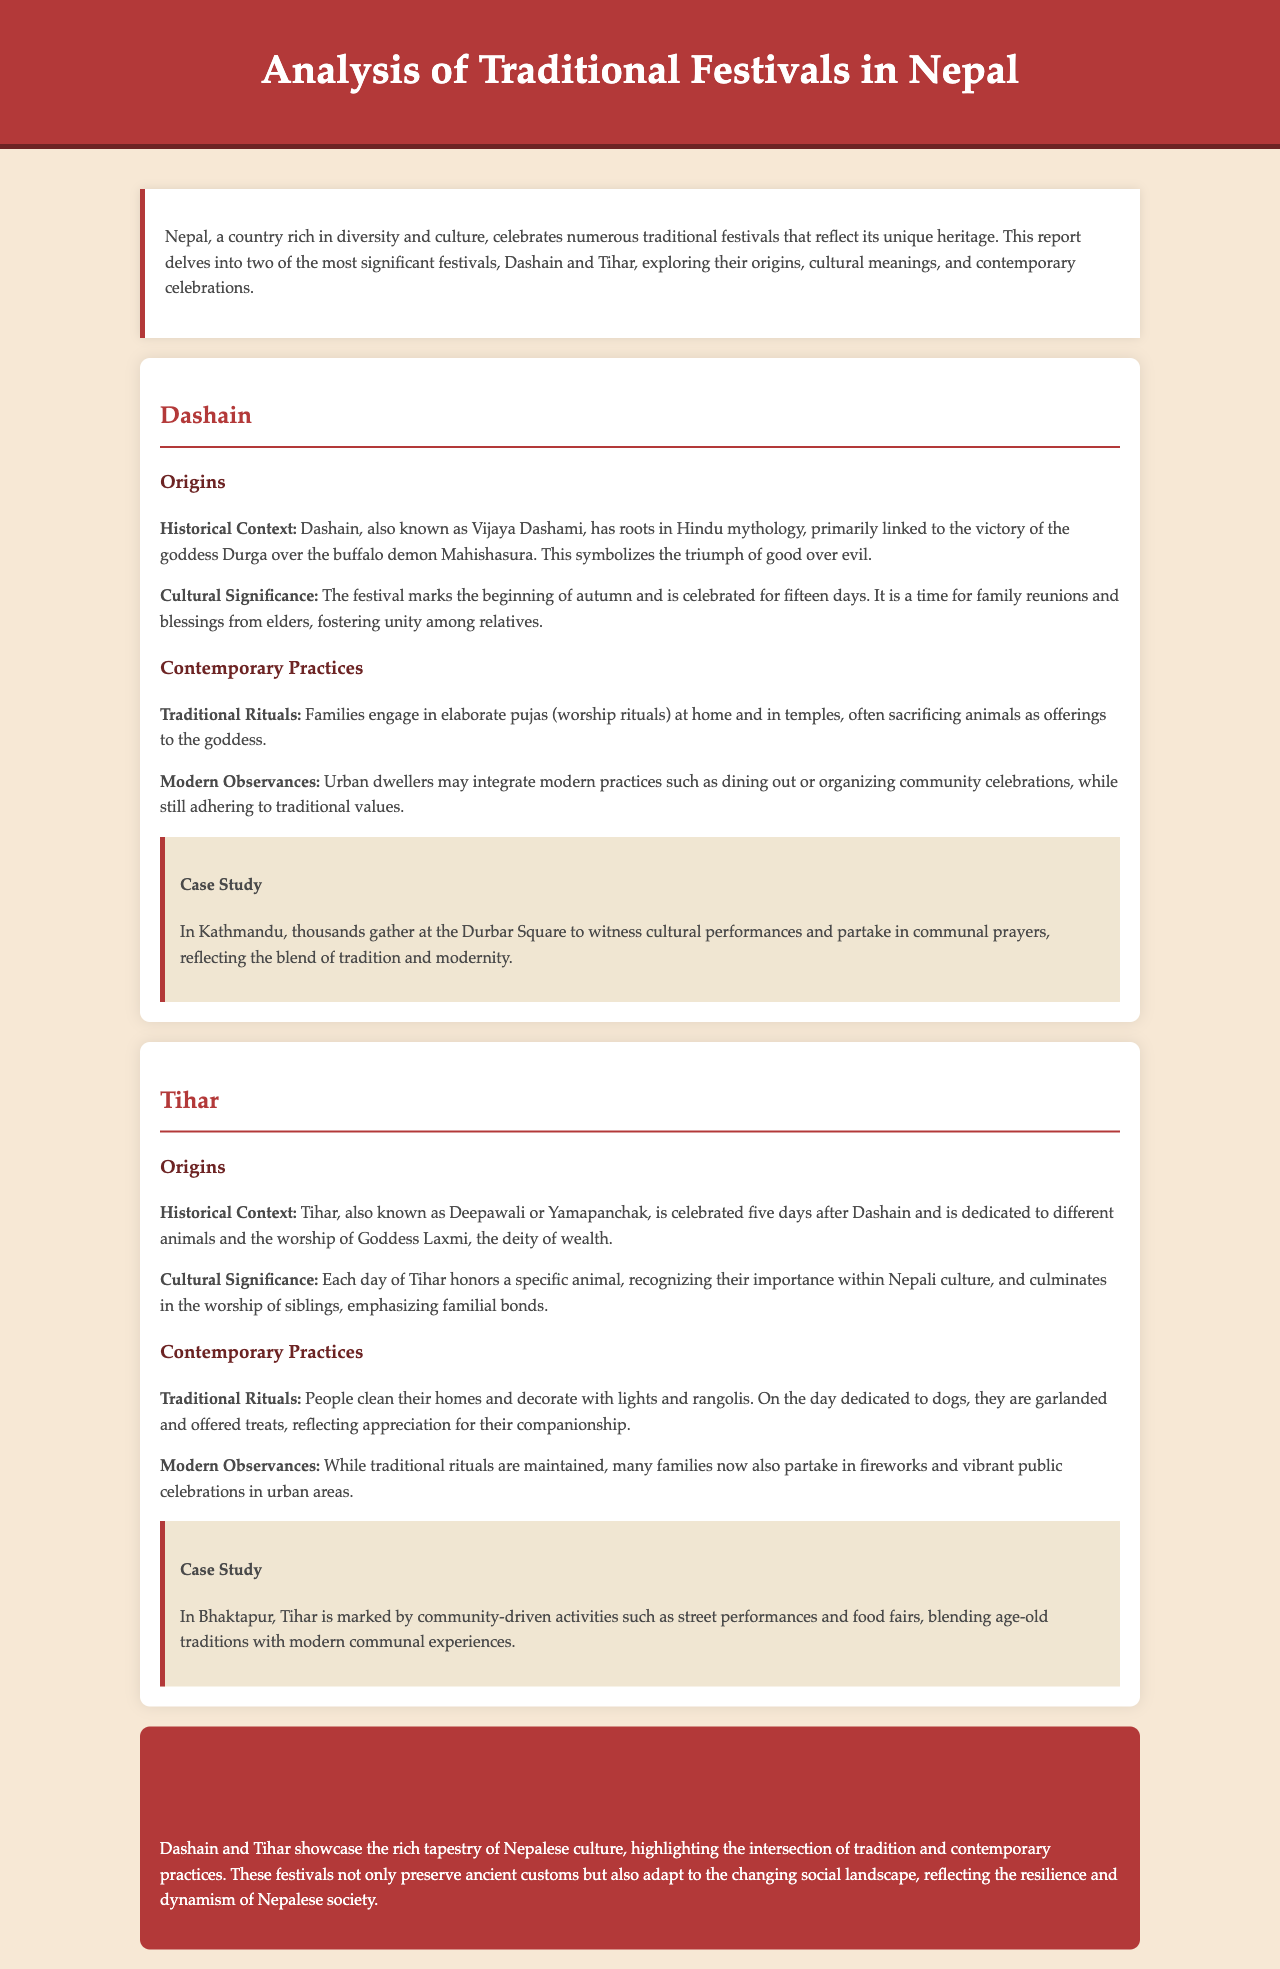What is the duration of Dashain? Dashain is celebrated for fifteen days, marking the beginning of autumn.
Answer: fifteen days What animal is garlanded and offered treats during Tihar? On the day dedicated to dogs, they are garlanded and offered treats, reflecting appreciation for their companionship.
Answer: dogs What is another name for Tihar? Tihar is also known as Deepawali or Yamapanchak.
Answer: Deepawali What significant cultural performance occurs in Kathmandu during Dashain? In Kathmandu, thousands gather at the Durbar Square to witness cultural performances and partake in communal prayers.
Answer: cultural performances What does the worship of Goddess Laxmi represent during Tihar? The worship of Goddess Laxmi, the deity of wealth, is a central theme during Tihar.
Answer: wealth What is the historical context of Dashain related to? Dashain is linked to the victory of the goddess Durga over the buffalo demon Mahishasura, symbolizing the triumph of good over evil.
Answer: goddess Durga What activities characterize Tihar celebrations in Bhaktapur? Tihar is marked by community-driven activities such as street performances and food fairs, blending age-old traditions with modern communal experiences.
Answer: street performances Which festival emphasizes familial bonds through the worship of siblings? Tihar culminates in the worship of siblings, emphasizing familial bonds.
Answer: Tihar 